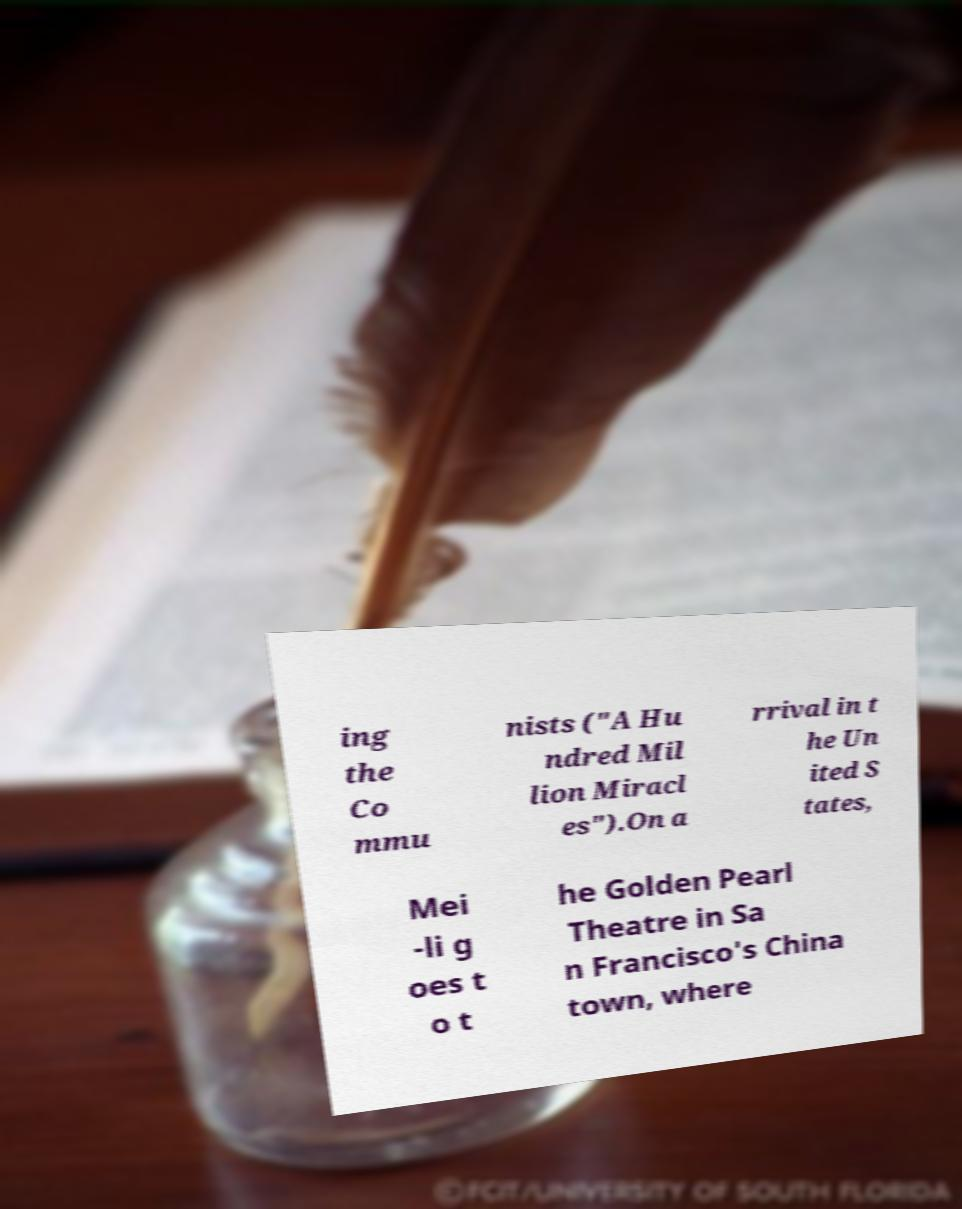Please read and relay the text visible in this image. What does it say? ing the Co mmu nists ("A Hu ndred Mil lion Miracl es").On a rrival in t he Un ited S tates, Mei -li g oes t o t he Golden Pearl Theatre in Sa n Francisco's China town, where 